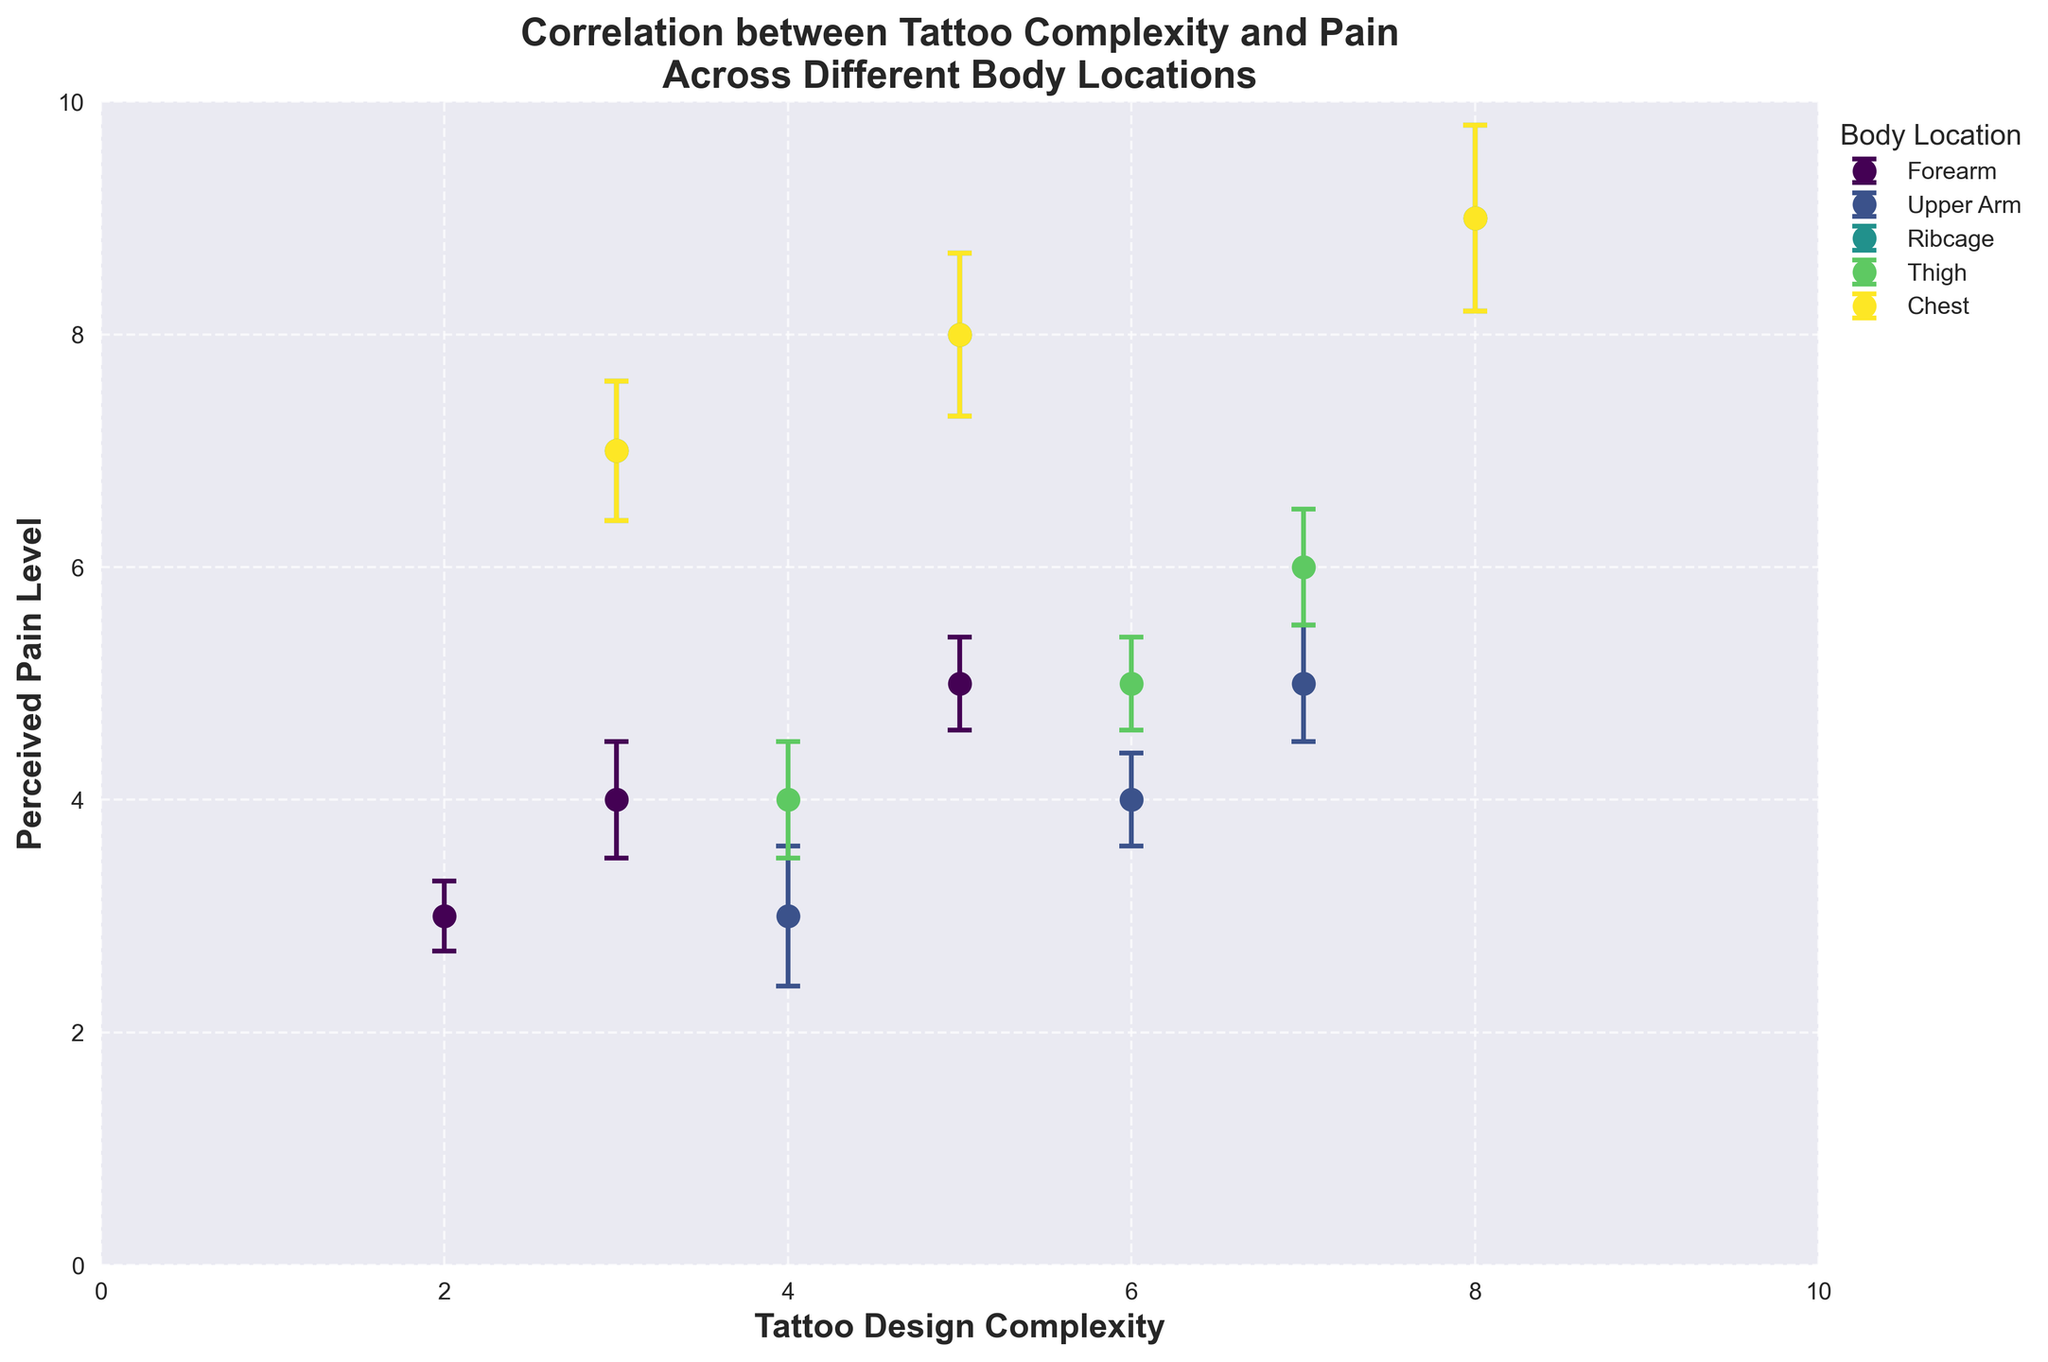What's the title of the figure? The title of the figure is located at the top, displayed in bold text.
Answer: Correlation between Tattoo Complexity and Pain Across Different Body Locations What are the two variables plotted on the x and y axes? The labels on the x and y axes indicate the variables being plotted. The x-axis represents 'Tattoo Design Complexity' and the y-axis represents 'Perceived Pain Level'.
Answer: Tattoo Design Complexity and Perceived Pain Level Which body location shows the highest perceived pain level for any given tattoo design complexity? We look for the highest point on the y-axis for each body location color. The highest perceived pain level is 9 for both Ribcage and Chest locations at different complexity levels.
Answer: Ribcage and Chest What is the average perceived pain level for tattoos with a complexity of 5 across all body locations? Identify the data points where 'Tattoo Design Complexity' is 5, then calculate the average of their 'Perceived Pain Level' values.
Answer: (5+8+5+8)/4 = 6.5 There are four body locations displayed. What are they? Refer to the legend on the plot which lists the body locations labeled with different colors.
Answer: Forearm, Upper Arm, Ribcage, Thigh, Chest How does the perceived pain level change for tattoos on the upper arm as the complexity increases from 4 to 7? Analyze the 'Upper Arm' data points. As complexity increases from 4 to 7, perceived pain levels change from 3 to 5, indicating an increase.
Answer: It increases Is there any body location where the perceived pain level is relatively constant regardless of tattoo complexity? Check if any body location has data points with similar 'Perceived Pain Level' across different complexities. The 'Forearm' shows very close pain levels of 3, 4, and 5 for complexities 2, 3, and 5, respectively.
Answer: Forearm What body location has the least variance in perceived pain levels for different tattoo complexities? Check the range of 'Perceived Pain Level' for each body location. The 'Upper Arm' ranges are smaller compared to other locations (from 3 to 5).
Answer: Upper Arm Which body location has the largest standard error in perceived pain levels? Inspect the error bars (caps) to determine their length. The largest error bar appears on the Ribcage data point with a complexity of 8 (error = 0.8).
Answer: Ribcage 